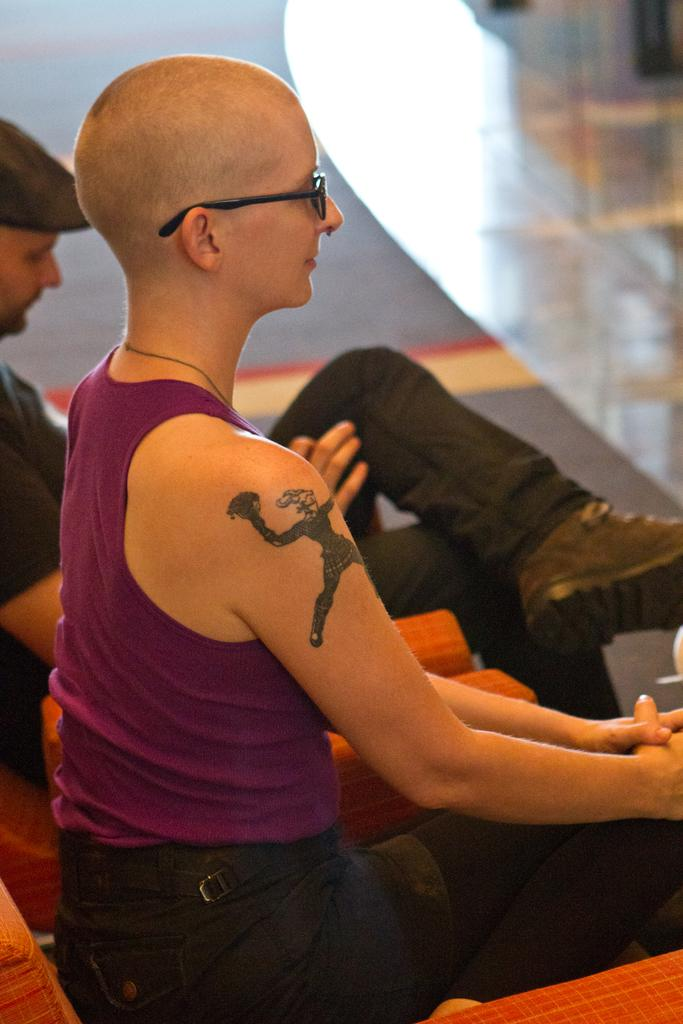How many people are sitting in the image? There are two people sitting on chairs in the image. What is in front of the people? There is a glass table in front of the people. What can be seen at the bottom of the image? The floor is visible at the bottom of the image. Where is the scarecrow located in the image? There is no scarecrow present in the image. What type of hole can be seen in the image? There is no hole visible in the image. 